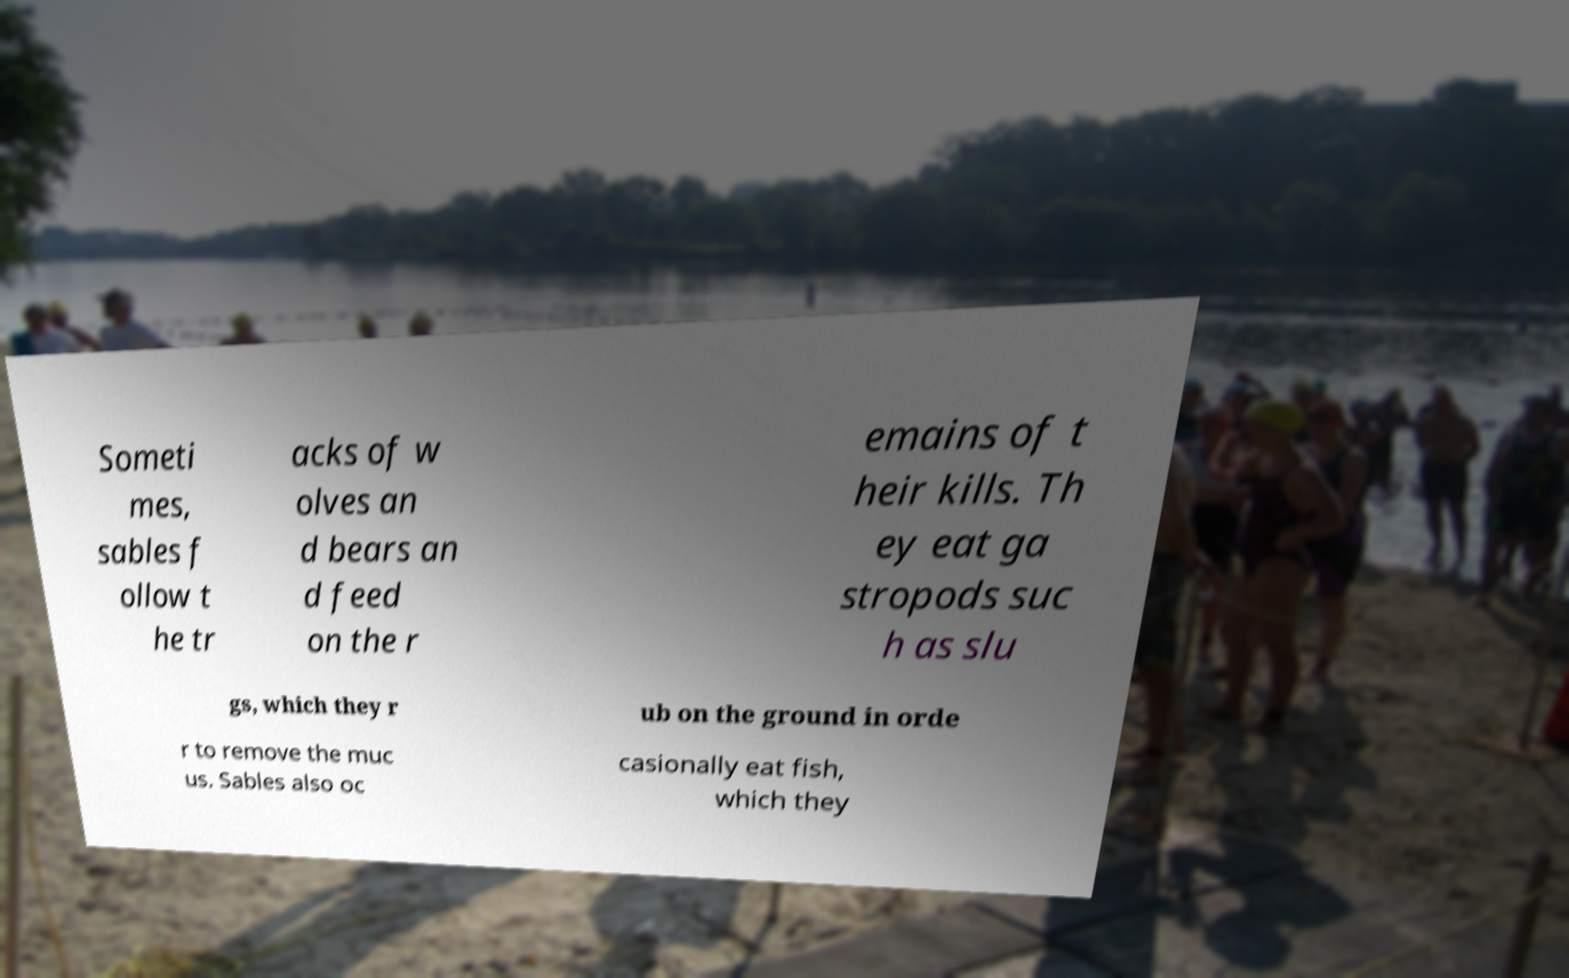Can you accurately transcribe the text from the provided image for me? Someti mes, sables f ollow t he tr acks of w olves an d bears an d feed on the r emains of t heir kills. Th ey eat ga stropods suc h as slu gs, which they r ub on the ground in orde r to remove the muc us. Sables also oc casionally eat fish, which they 